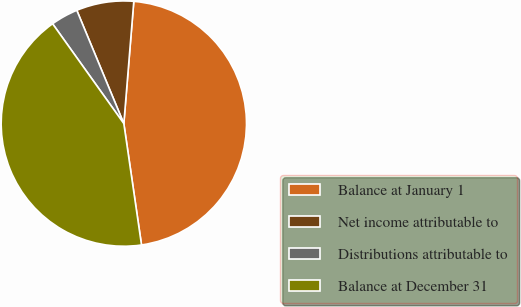Convert chart to OTSL. <chart><loc_0><loc_0><loc_500><loc_500><pie_chart><fcel>Balance at January 1<fcel>Net income attributable to<fcel>Distributions attributable to<fcel>Balance at December 31<nl><fcel>46.4%<fcel>7.56%<fcel>3.6%<fcel>42.44%<nl></chart> 